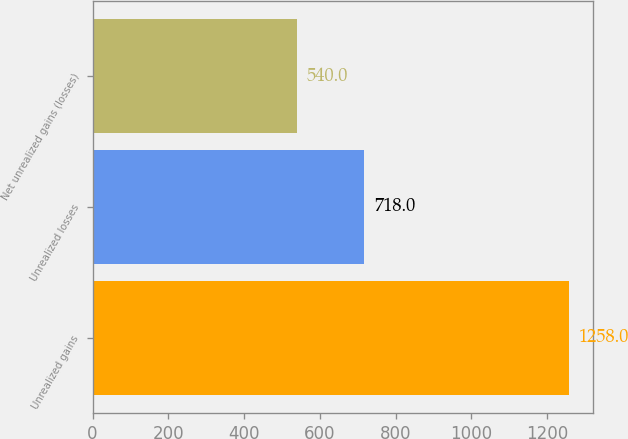Convert chart. <chart><loc_0><loc_0><loc_500><loc_500><bar_chart><fcel>Unrealized gains<fcel>Unrealized losses<fcel>Net unrealized gains (losses)<nl><fcel>1258<fcel>718<fcel>540<nl></chart> 